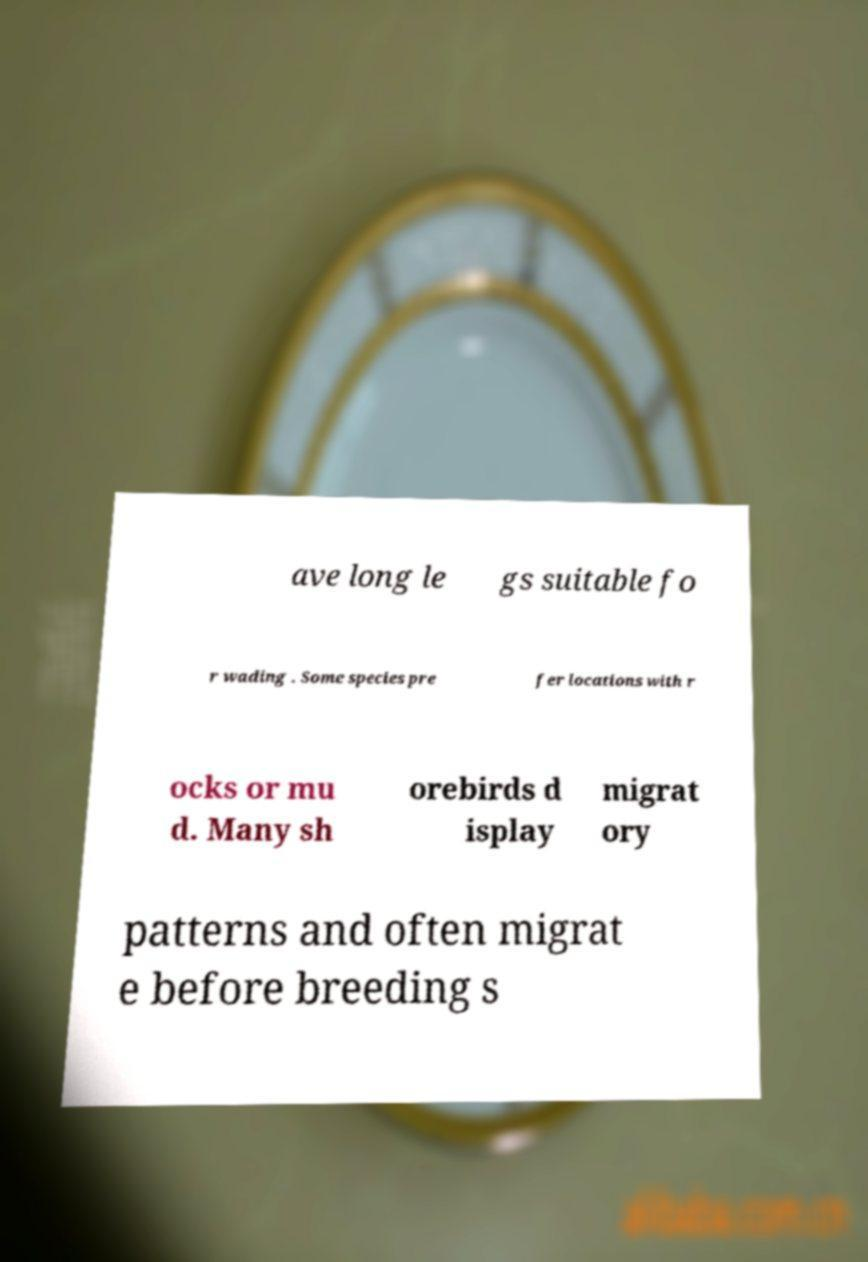For documentation purposes, I need the text within this image transcribed. Could you provide that? ave long le gs suitable fo r wading . Some species pre fer locations with r ocks or mu d. Many sh orebirds d isplay migrat ory patterns and often migrat e before breeding s 